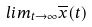Convert formula to latex. <formula><loc_0><loc_0><loc_500><loc_500>l i m _ { t \rightarrow \infty } \overline { x } ( t )</formula> 